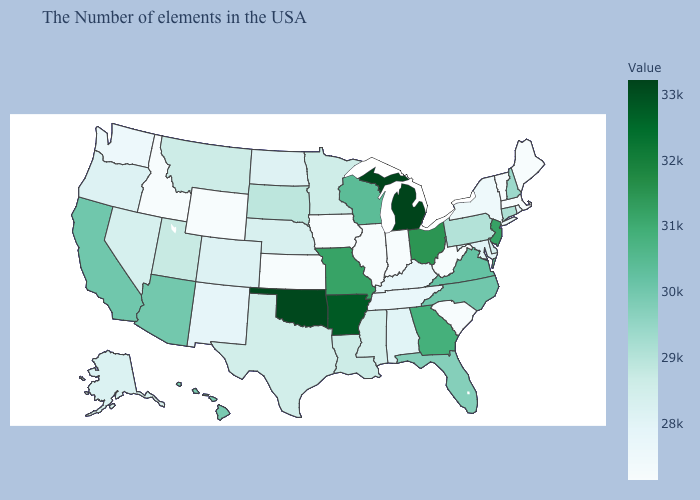Does the map have missing data?
Write a very short answer. No. Does Washington have a higher value than Connecticut?
Give a very brief answer. No. Which states have the lowest value in the USA?
Answer briefly. Maine, Massachusetts, Vermont, South Carolina, West Virginia, Indiana, Illinois, Iowa, Kansas, Wyoming, Idaho. Does Michigan have the highest value in the USA?
Give a very brief answer. Yes. Among the states that border Maryland , does Delaware have the lowest value?
Concise answer only. No. Does Indiana have the highest value in the USA?
Write a very short answer. No. 